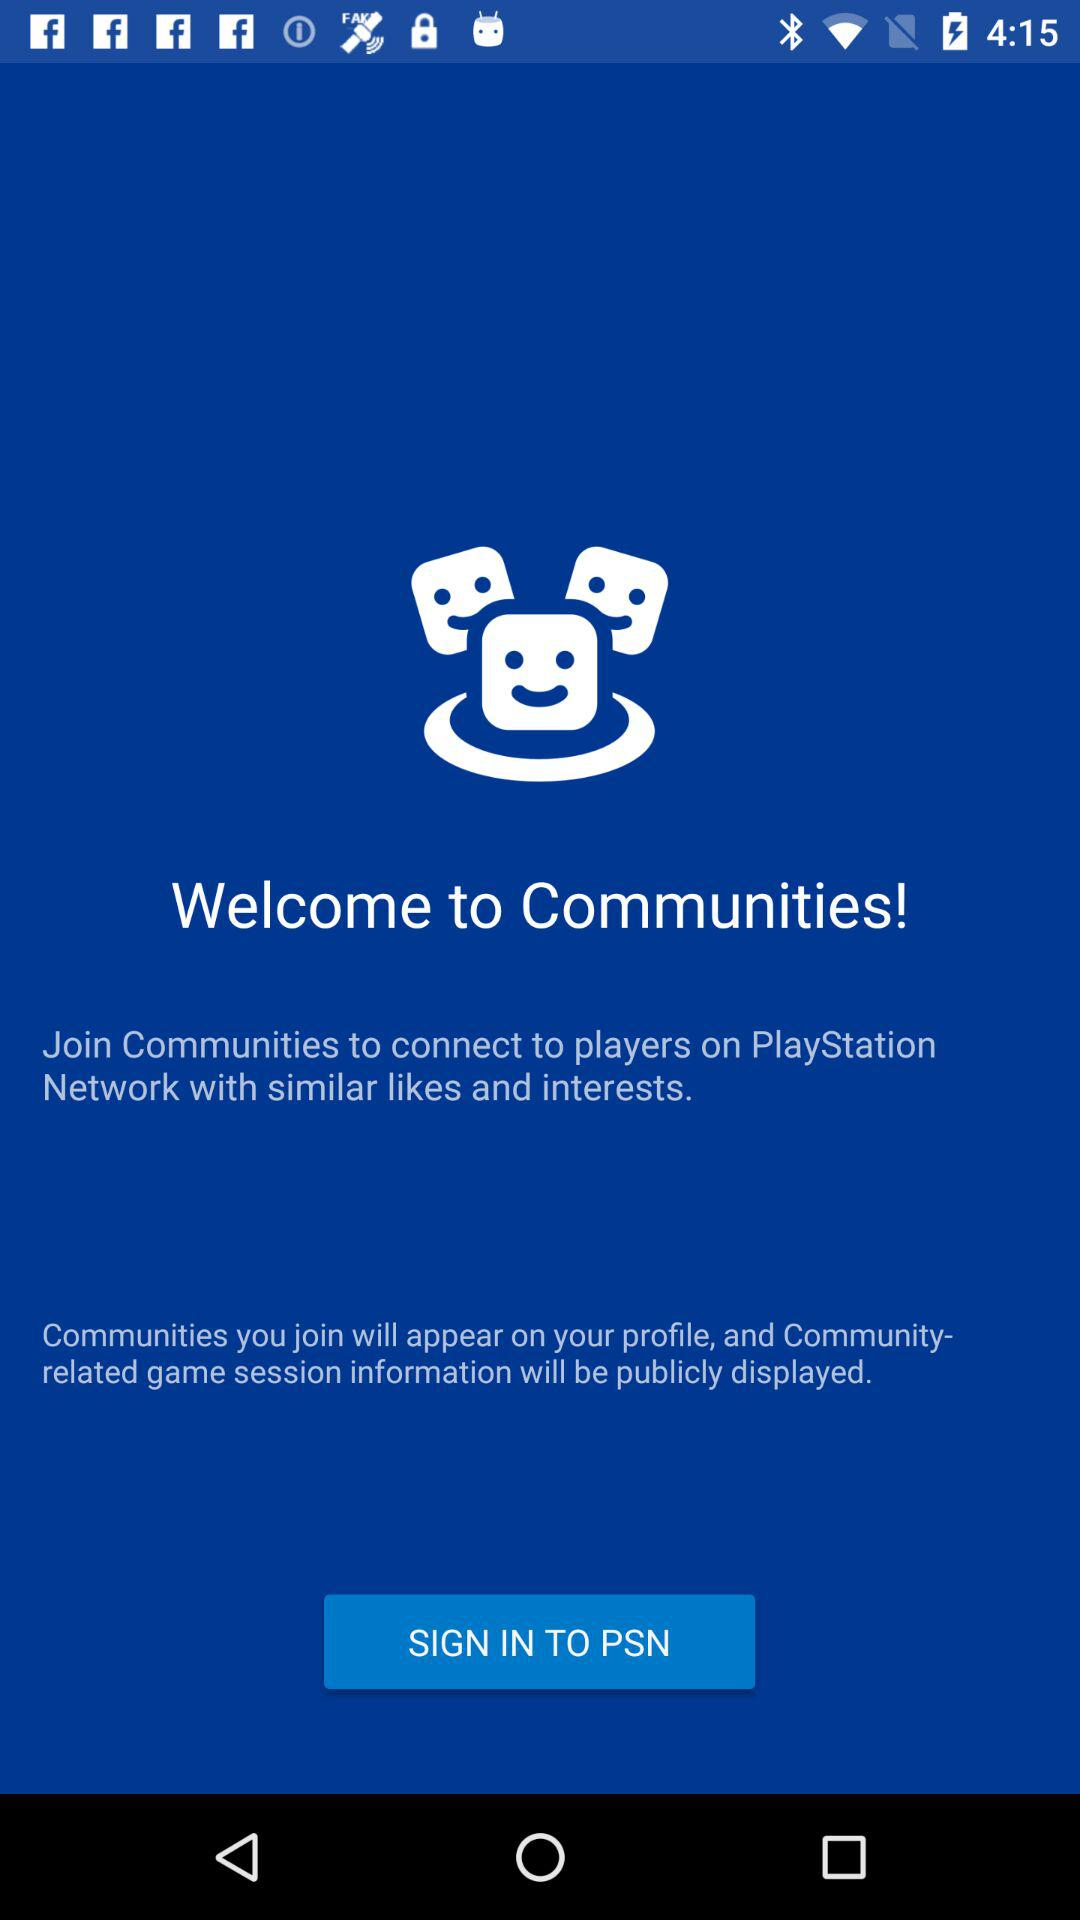What is the application name?
When the provided information is insufficient, respond with <no answer>. <no answer> 